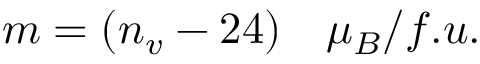Convert formula to latex. <formula><loc_0><loc_0><loc_500><loc_500>m = ( n _ { v } - 2 4 ) \quad m u _ { B } / f . u .</formula> 